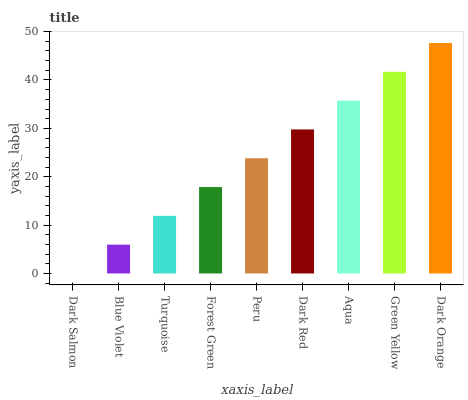Is Dark Salmon the minimum?
Answer yes or no. Yes. Is Dark Orange the maximum?
Answer yes or no. Yes. Is Blue Violet the minimum?
Answer yes or no. No. Is Blue Violet the maximum?
Answer yes or no. No. Is Blue Violet greater than Dark Salmon?
Answer yes or no. Yes. Is Dark Salmon less than Blue Violet?
Answer yes or no. Yes. Is Dark Salmon greater than Blue Violet?
Answer yes or no. No. Is Blue Violet less than Dark Salmon?
Answer yes or no. No. Is Peru the high median?
Answer yes or no. Yes. Is Peru the low median?
Answer yes or no. Yes. Is Dark Red the high median?
Answer yes or no. No. Is Aqua the low median?
Answer yes or no. No. 